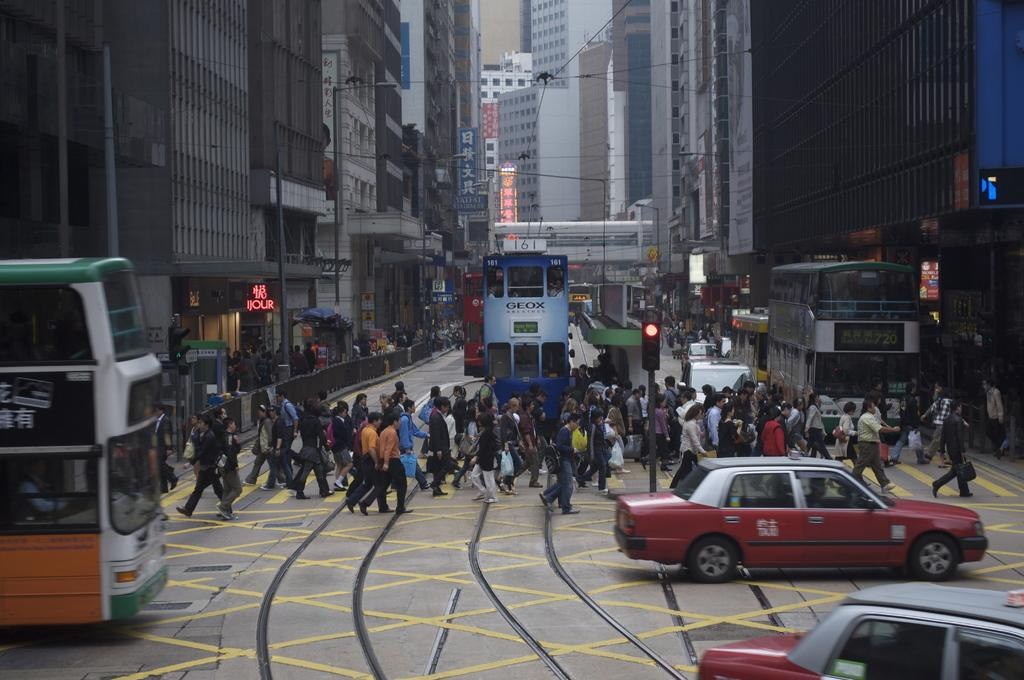<image>
Create a compact narrative representing the image presented. Geox is advertised on the blue double decker tram. 